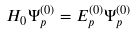<formula> <loc_0><loc_0><loc_500><loc_500>H _ { 0 } \Psi _ { p } ^ { ( 0 ) } = E _ { p } ^ { ( 0 ) } \Psi _ { p } ^ { ( 0 ) }</formula> 